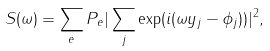<formula> <loc_0><loc_0><loc_500><loc_500>S ( \omega ) = \sum _ { e } P _ { e } | \sum _ { j } \exp ( i ( \omega y _ { j } - \phi _ { j } ) ) | ^ { 2 } ,</formula> 